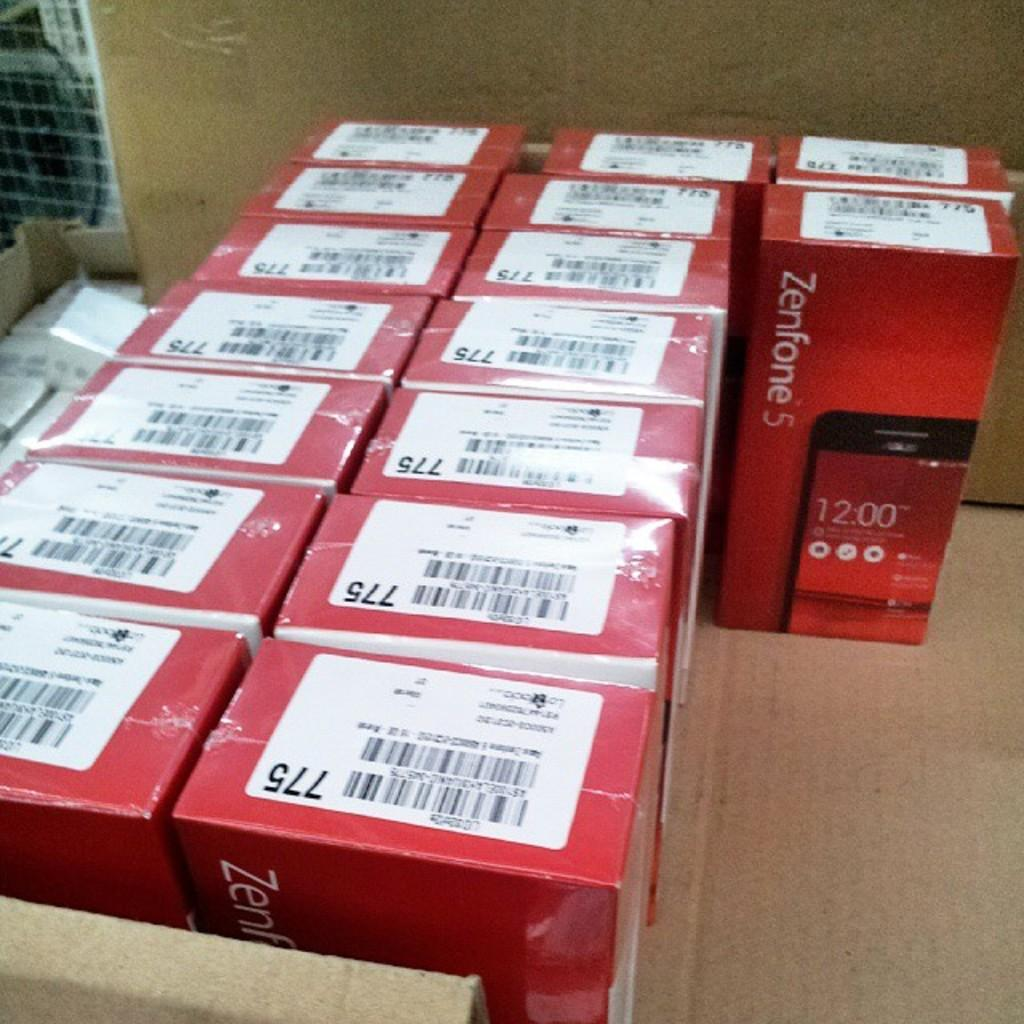<image>
Summarize the visual content of the image. sixteen red boxes of zenfone 5 that have sticker on top with number 775 